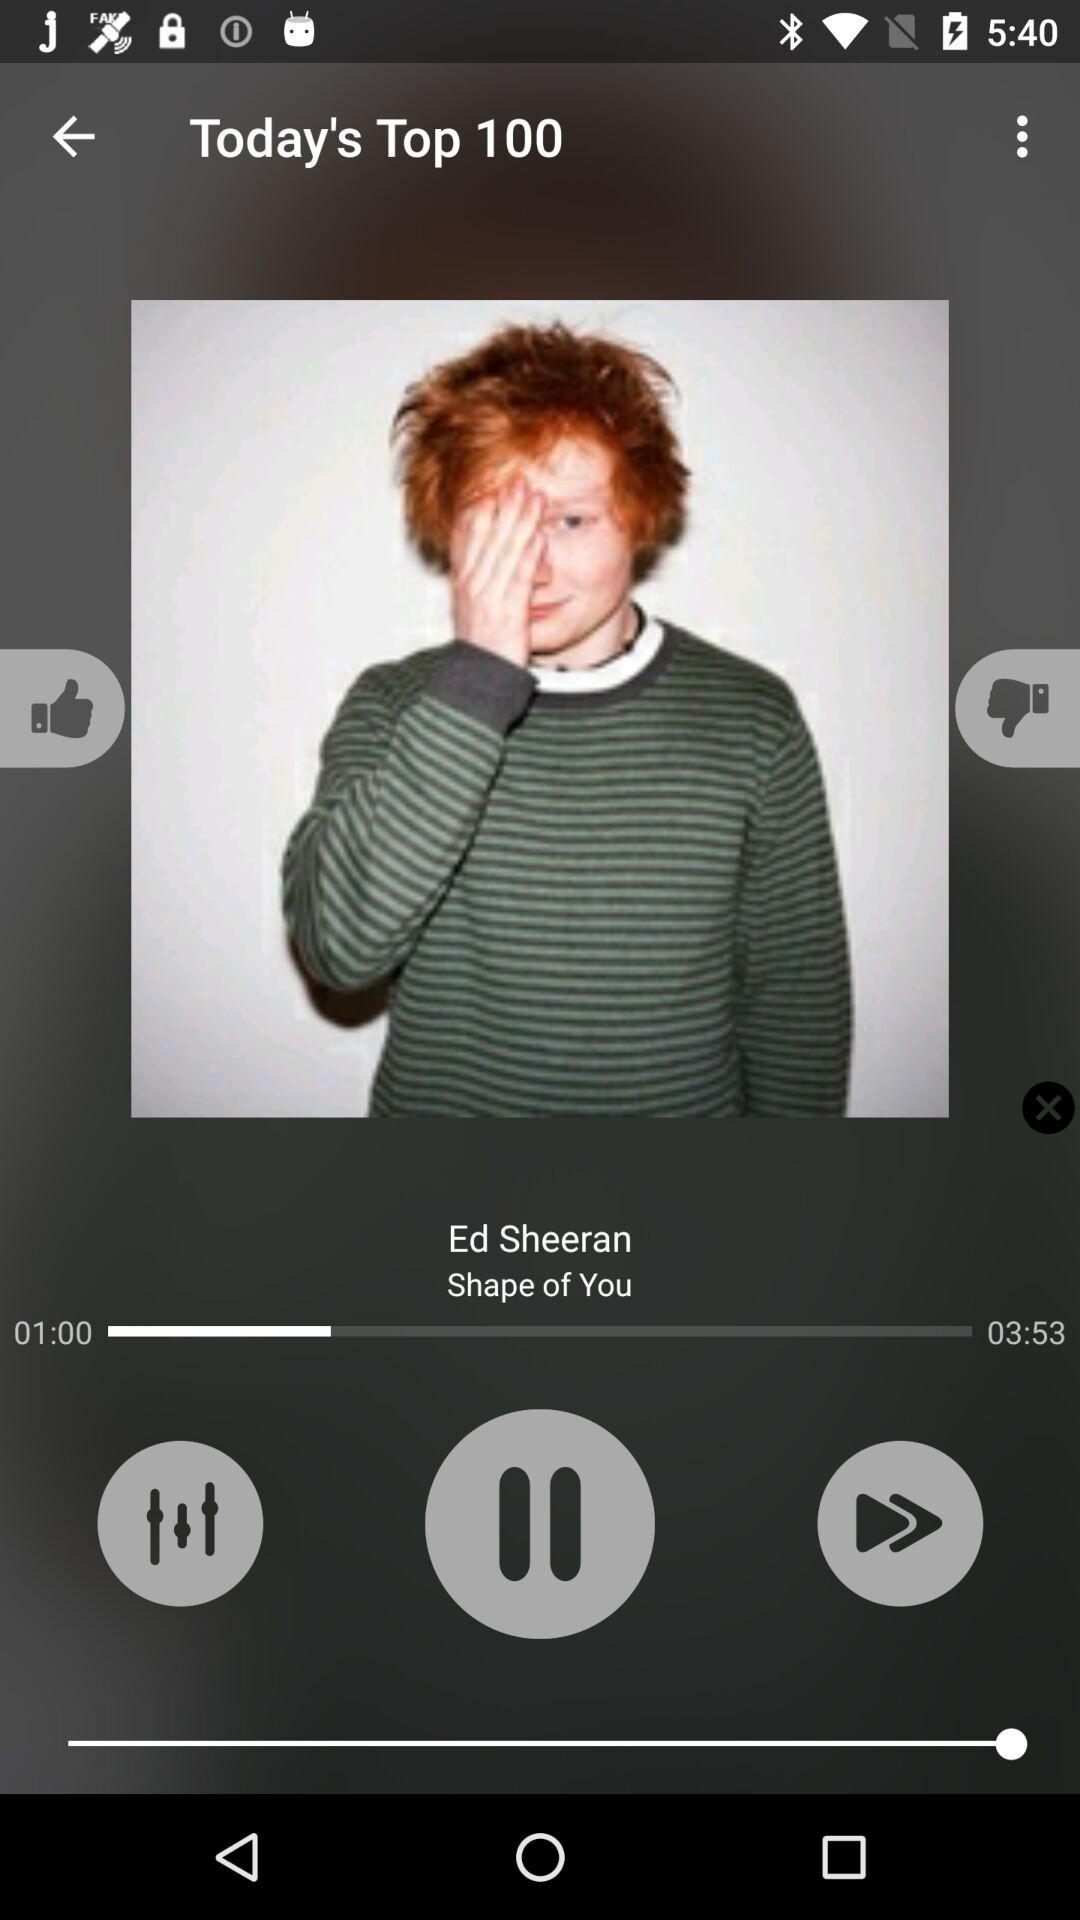Who is the singer? The singer is Ed Sheeran. 